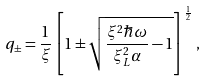<formula> <loc_0><loc_0><loc_500><loc_500>q _ { \pm } = \frac { 1 } { \xi } \left [ 1 \pm \sqrt { \frac { \xi ^ { 2 } \hbar { \omega } } { \xi ^ { 2 } _ { L } \alpha } - 1 } \right ] ^ { \frac { 1 } { 2 } } \, ,</formula> 